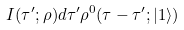Convert formula to latex. <formula><loc_0><loc_0><loc_500><loc_500>I ( \tau ^ { \prime } ; \rho ) d \tau ^ { \prime } \rho ^ { 0 } ( \tau - \tau ^ { \prime } ; | 1 \rangle )</formula> 